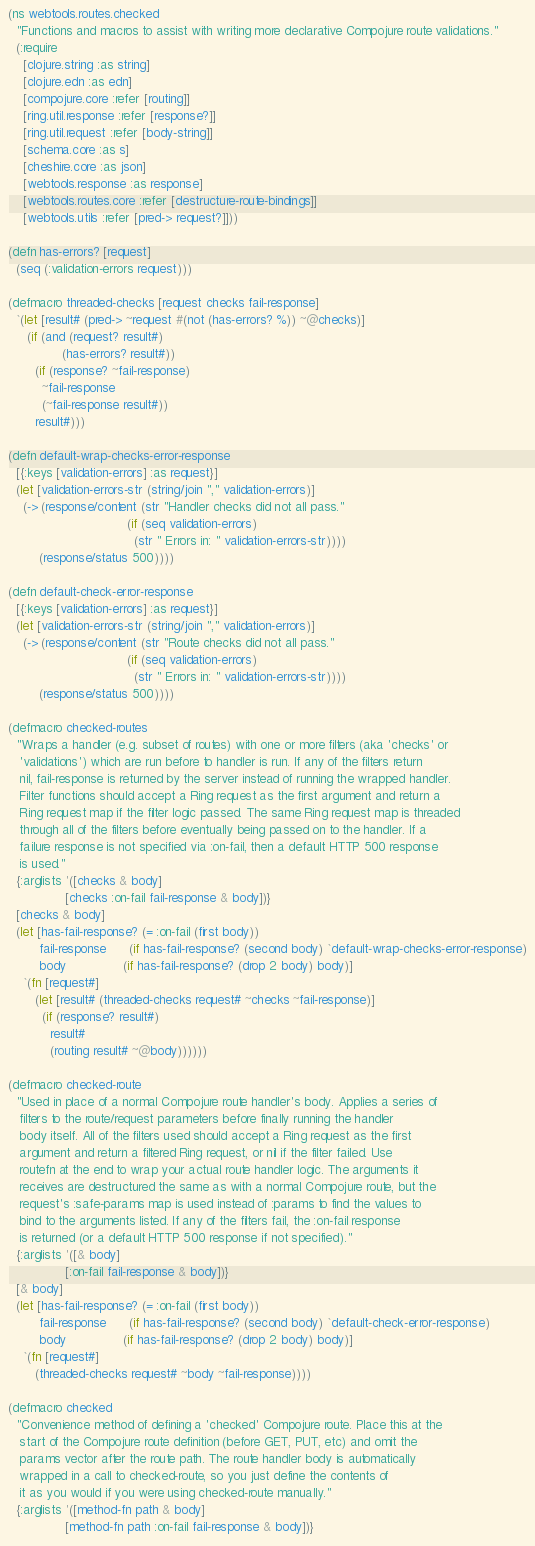Convert code to text. <code><loc_0><loc_0><loc_500><loc_500><_Clojure_>(ns webtools.routes.checked
  "Functions and macros to assist with writing more declarative Compojure route validations."
  (:require
    [clojure.string :as string]
    [clojure.edn :as edn]
    [compojure.core :refer [routing]]
    [ring.util.response :refer [response?]]
    [ring.util.request :refer [body-string]]
    [schema.core :as s]
    [cheshire.core :as json]
    [webtools.response :as response]
    [webtools.routes.core :refer [destructure-route-bindings]]
    [webtools.utils :refer [pred-> request?]]))

(defn has-errors? [request]
  (seq (:validation-errors request)))

(defmacro threaded-checks [request checks fail-response]
  `(let [result# (pred-> ~request #(not (has-errors? %)) ~@checks)]
     (if (and (request? result#)
              (has-errors? result#))
       (if (response? ~fail-response)
         ~fail-response
         (~fail-response result#))
       result#)))

(defn default-wrap-checks-error-response
  [{:keys [validation-errors] :as request}]
  (let [validation-errors-str (string/join "," validation-errors)]
    (-> (response/content (str "Handler checks did not all pass."
                               (if (seq validation-errors)
                                 (str " Errors in: " validation-errors-str))))
        (response/status 500))))

(defn default-check-error-response
  [{:keys [validation-errors] :as request}]
  (let [validation-errors-str (string/join "," validation-errors)]
    (-> (response/content (str "Route checks did not all pass."
                               (if (seq validation-errors)
                                 (str " Errors in: " validation-errors-str))))
        (response/status 500))))

(defmacro checked-routes
  "Wraps a handler (e.g. subset of routes) with one or more filters (aka 'checks' or
   'validations') which are run before to handler is run. If any of the filters return
   nil, fail-response is returned by the server instead of running the wrapped handler.
   Filter functions should accept a Ring request as the first argument and return a
   Ring request map if the filter logic passed. The same Ring request map is threaded
   through all of the filters before eventually being passed on to the handler. If a
   failure response is not specified via :on-fail, then a default HTTP 500 response
   is used."
  {:arglists '([checks & body]
               [checks :on-fail fail-response & body])}
  [checks & body]
  (let [has-fail-response? (= :on-fail (first body))
        fail-response      (if has-fail-response? (second body) `default-wrap-checks-error-response)
        body               (if has-fail-response? (drop 2 body) body)]
    `(fn [request#]
       (let [result# (threaded-checks request# ~checks ~fail-response)]
         (if (response? result#)
           result#
           (routing result# ~@body))))))

(defmacro checked-route
  "Used in place of a normal Compojure route handler's body. Applies a series of
   filters to the route/request parameters before finally running the handler
   body itself. All of the filters used should accept a Ring request as the first
   argument and return a filtered Ring request, or nil if the filter failed. Use
   routefn at the end to wrap your actual route handler logic. The arguments it
   receives are destructured the same as with a normal Compojure route, but the
   request's :safe-params map is used instead of :params to find the values to
   bind to the arguments listed. If any of the filters fail, the :on-fail response
   is returned (or a default HTTP 500 response if not specified)."
  {:arglists '([& body]
               [:on-fail fail-response & body])}
  [& body]
  (let [has-fail-response? (= :on-fail (first body))
        fail-response      (if has-fail-response? (second body) `default-check-error-response)
        body               (if has-fail-response? (drop 2 body) body)]
    `(fn [request#]
       (threaded-checks request# ~body ~fail-response))))

(defmacro checked
  "Convenience method of defining a 'checked' Compojure route. Place this at the
   start of the Compojure route definition (before GET, PUT, etc) and omit the
   params vector after the route path. The route handler body is automatically
   wrapped in a call to checked-route, so you just define the contents of
   it as you would if you were using checked-route manually."
  {:arglists '([method-fn path & body]
               [method-fn path :on-fail fail-response & body])}</code> 